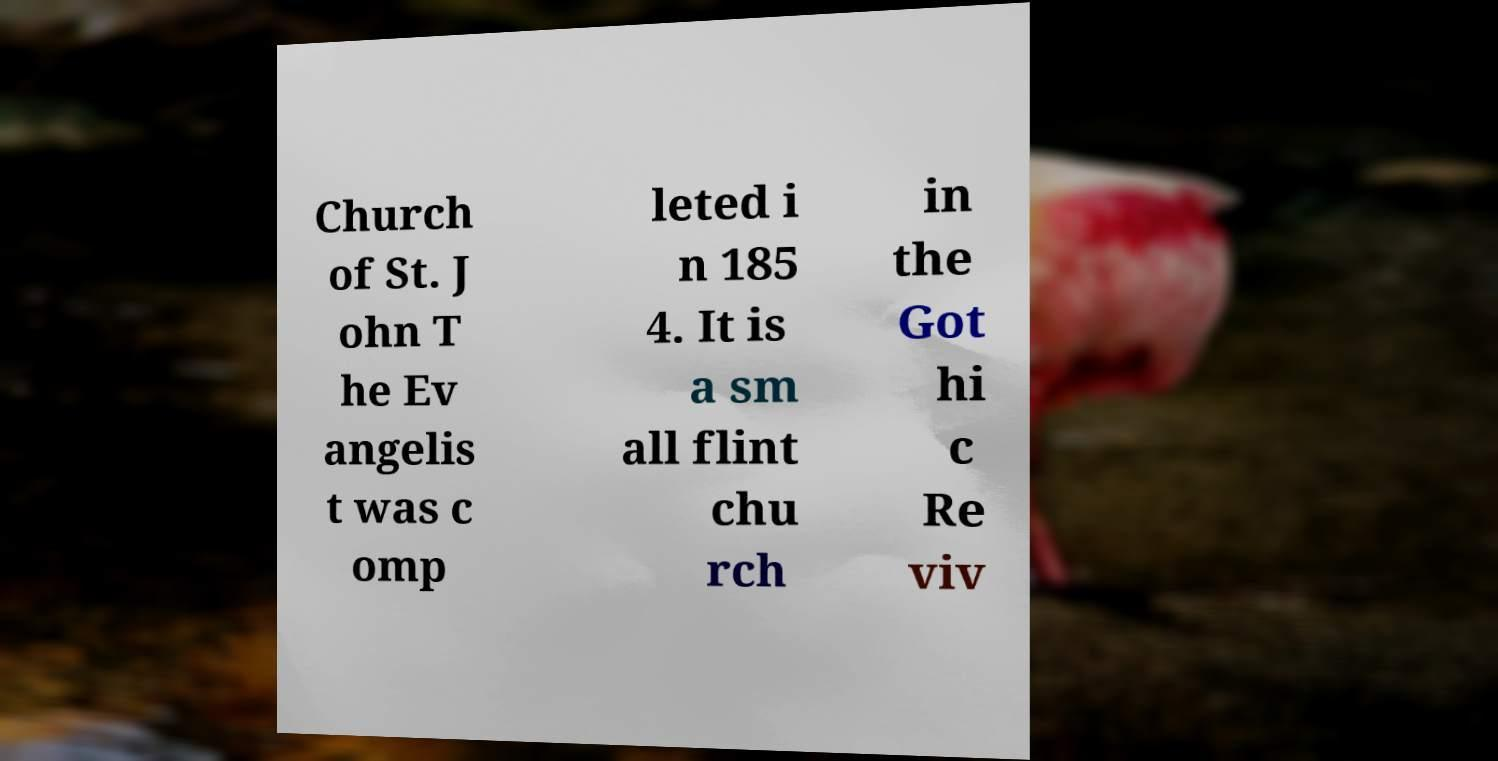There's text embedded in this image that I need extracted. Can you transcribe it verbatim? Church of St. J ohn T he Ev angelis t was c omp leted i n 185 4. It is a sm all flint chu rch in the Got hi c Re viv 